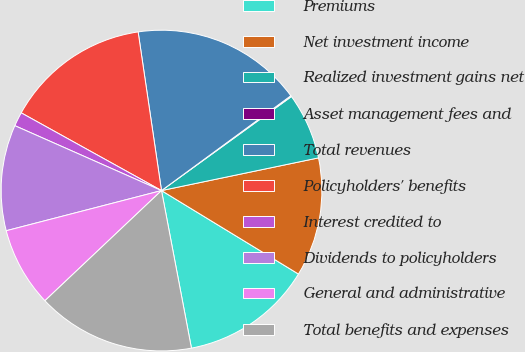Convert chart. <chart><loc_0><loc_0><loc_500><loc_500><pie_chart><fcel>Premiums<fcel>Net investment income<fcel>Realized investment gains net<fcel>Asset management fees and<fcel>Total revenues<fcel>Policyholders' benefits<fcel>Interest credited to<fcel>Dividends to policyholders<fcel>General and administrative<fcel>Total benefits and expenses<nl><fcel>13.3%<fcel>11.98%<fcel>6.7%<fcel>0.1%<fcel>17.26%<fcel>14.62%<fcel>1.42%<fcel>10.66%<fcel>8.02%<fcel>15.94%<nl></chart> 